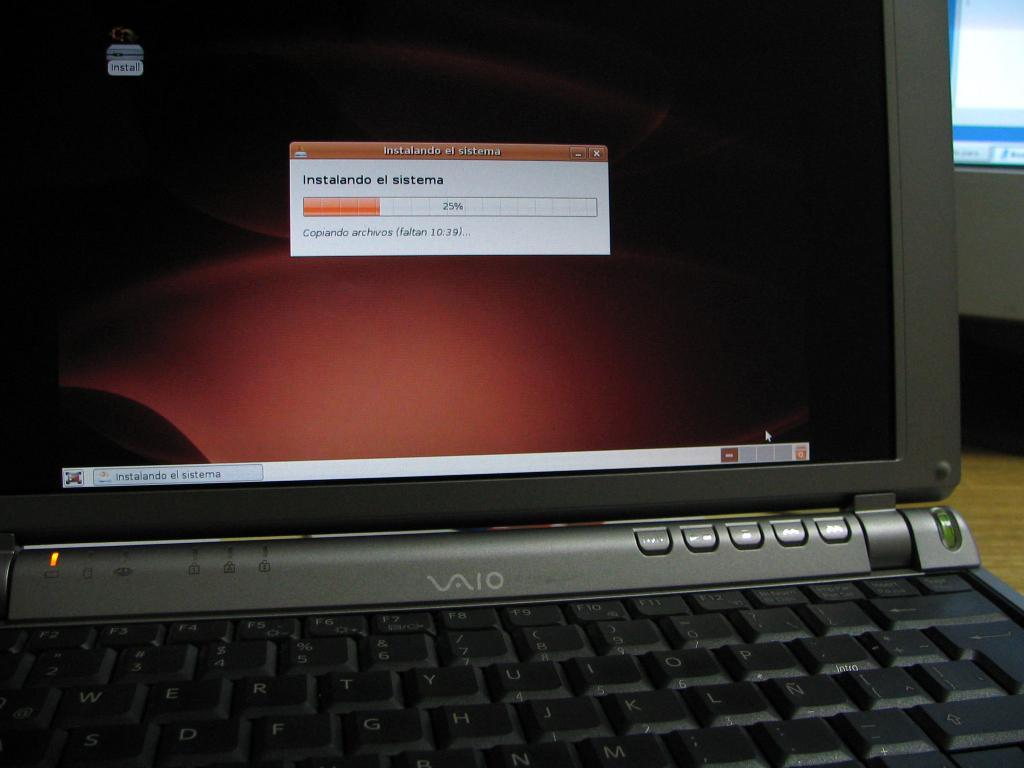What brand of laptop is this?
Keep it short and to the point. Vaio. 